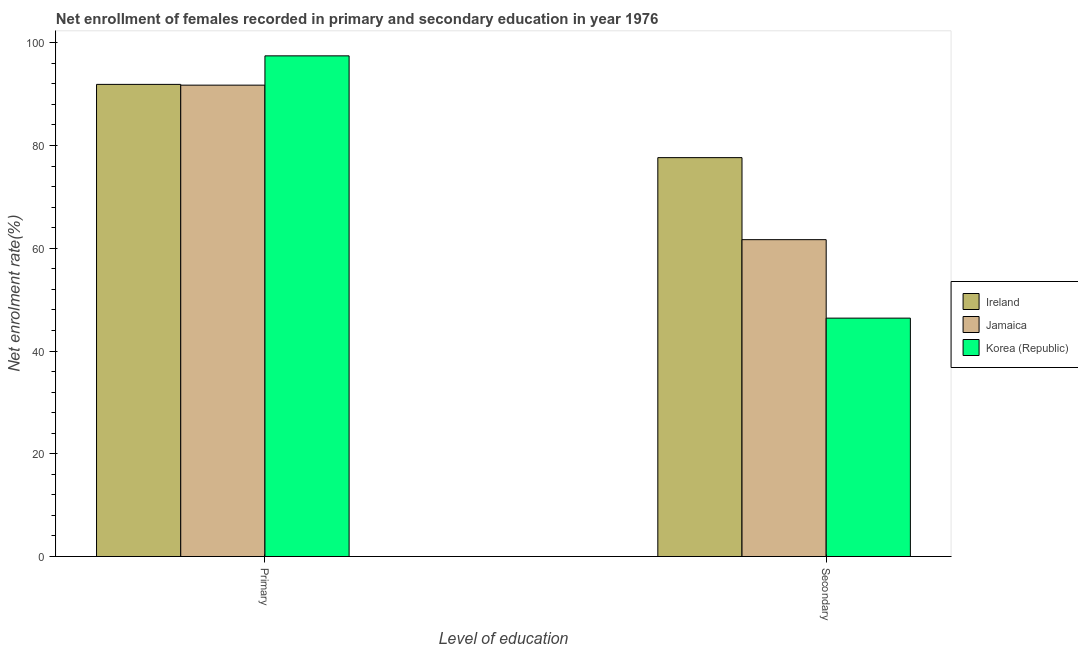Are the number of bars per tick equal to the number of legend labels?
Provide a short and direct response. Yes. Are the number of bars on each tick of the X-axis equal?
Ensure brevity in your answer.  Yes. What is the label of the 2nd group of bars from the left?
Your answer should be very brief. Secondary. What is the enrollment rate in primary education in Korea (Republic)?
Make the answer very short. 97.44. Across all countries, what is the maximum enrollment rate in primary education?
Provide a succinct answer. 97.44. Across all countries, what is the minimum enrollment rate in primary education?
Ensure brevity in your answer.  91.74. In which country was the enrollment rate in primary education minimum?
Offer a terse response. Jamaica. What is the total enrollment rate in secondary education in the graph?
Your answer should be compact. 185.7. What is the difference between the enrollment rate in primary education in Ireland and that in Jamaica?
Offer a terse response. 0.15. What is the difference between the enrollment rate in primary education in Jamaica and the enrollment rate in secondary education in Korea (Republic)?
Provide a succinct answer. 45.35. What is the average enrollment rate in secondary education per country?
Ensure brevity in your answer.  61.9. What is the difference between the enrollment rate in secondary education and enrollment rate in primary education in Jamaica?
Keep it short and to the point. -30.08. What is the ratio of the enrollment rate in primary education in Korea (Republic) to that in Ireland?
Keep it short and to the point. 1.06. Is the enrollment rate in secondary education in Ireland less than that in Jamaica?
Give a very brief answer. No. What does the 1st bar from the left in Secondary represents?
Give a very brief answer. Ireland. What does the 3rd bar from the right in Primary represents?
Offer a very short reply. Ireland. Are all the bars in the graph horizontal?
Ensure brevity in your answer.  No. How many countries are there in the graph?
Keep it short and to the point. 3. Does the graph contain grids?
Your answer should be very brief. No. How are the legend labels stacked?
Ensure brevity in your answer.  Vertical. What is the title of the graph?
Offer a terse response. Net enrollment of females recorded in primary and secondary education in year 1976. Does "Yemen, Rep." appear as one of the legend labels in the graph?
Make the answer very short. No. What is the label or title of the X-axis?
Provide a succinct answer. Level of education. What is the label or title of the Y-axis?
Provide a short and direct response. Net enrolment rate(%). What is the Net enrolment rate(%) of Ireland in Primary?
Your answer should be very brief. 91.89. What is the Net enrolment rate(%) in Jamaica in Primary?
Give a very brief answer. 91.74. What is the Net enrolment rate(%) in Korea (Republic) in Primary?
Your answer should be very brief. 97.44. What is the Net enrolment rate(%) of Ireland in Secondary?
Keep it short and to the point. 77.63. What is the Net enrolment rate(%) of Jamaica in Secondary?
Ensure brevity in your answer.  61.67. What is the Net enrolment rate(%) of Korea (Republic) in Secondary?
Provide a short and direct response. 46.4. Across all Level of education, what is the maximum Net enrolment rate(%) of Ireland?
Your answer should be compact. 91.89. Across all Level of education, what is the maximum Net enrolment rate(%) of Jamaica?
Keep it short and to the point. 91.74. Across all Level of education, what is the maximum Net enrolment rate(%) of Korea (Republic)?
Keep it short and to the point. 97.44. Across all Level of education, what is the minimum Net enrolment rate(%) of Ireland?
Provide a short and direct response. 77.63. Across all Level of education, what is the minimum Net enrolment rate(%) in Jamaica?
Your answer should be very brief. 61.67. Across all Level of education, what is the minimum Net enrolment rate(%) in Korea (Republic)?
Offer a terse response. 46.4. What is the total Net enrolment rate(%) of Ireland in the graph?
Offer a terse response. 169.53. What is the total Net enrolment rate(%) of Jamaica in the graph?
Make the answer very short. 153.41. What is the total Net enrolment rate(%) in Korea (Republic) in the graph?
Your answer should be compact. 143.84. What is the difference between the Net enrolment rate(%) of Ireland in Primary and that in Secondary?
Provide a succinct answer. 14.26. What is the difference between the Net enrolment rate(%) in Jamaica in Primary and that in Secondary?
Ensure brevity in your answer.  30.08. What is the difference between the Net enrolment rate(%) in Korea (Republic) in Primary and that in Secondary?
Your answer should be very brief. 51.05. What is the difference between the Net enrolment rate(%) in Ireland in Primary and the Net enrolment rate(%) in Jamaica in Secondary?
Provide a succinct answer. 30.22. What is the difference between the Net enrolment rate(%) of Ireland in Primary and the Net enrolment rate(%) of Korea (Republic) in Secondary?
Give a very brief answer. 45.49. What is the difference between the Net enrolment rate(%) in Jamaica in Primary and the Net enrolment rate(%) in Korea (Republic) in Secondary?
Make the answer very short. 45.35. What is the average Net enrolment rate(%) in Ireland per Level of education?
Make the answer very short. 84.76. What is the average Net enrolment rate(%) in Jamaica per Level of education?
Offer a terse response. 76.7. What is the average Net enrolment rate(%) in Korea (Republic) per Level of education?
Make the answer very short. 71.92. What is the difference between the Net enrolment rate(%) in Ireland and Net enrolment rate(%) in Jamaica in Primary?
Provide a short and direct response. 0.15. What is the difference between the Net enrolment rate(%) in Ireland and Net enrolment rate(%) in Korea (Republic) in Primary?
Your response must be concise. -5.55. What is the difference between the Net enrolment rate(%) of Jamaica and Net enrolment rate(%) of Korea (Republic) in Primary?
Provide a succinct answer. -5.7. What is the difference between the Net enrolment rate(%) in Ireland and Net enrolment rate(%) in Jamaica in Secondary?
Your response must be concise. 15.97. What is the difference between the Net enrolment rate(%) in Ireland and Net enrolment rate(%) in Korea (Republic) in Secondary?
Make the answer very short. 31.24. What is the difference between the Net enrolment rate(%) of Jamaica and Net enrolment rate(%) of Korea (Republic) in Secondary?
Provide a succinct answer. 15.27. What is the ratio of the Net enrolment rate(%) in Ireland in Primary to that in Secondary?
Ensure brevity in your answer.  1.18. What is the ratio of the Net enrolment rate(%) in Jamaica in Primary to that in Secondary?
Your response must be concise. 1.49. What is the ratio of the Net enrolment rate(%) of Korea (Republic) in Primary to that in Secondary?
Offer a very short reply. 2.1. What is the difference between the highest and the second highest Net enrolment rate(%) of Ireland?
Provide a short and direct response. 14.26. What is the difference between the highest and the second highest Net enrolment rate(%) in Jamaica?
Make the answer very short. 30.08. What is the difference between the highest and the second highest Net enrolment rate(%) of Korea (Republic)?
Your answer should be compact. 51.05. What is the difference between the highest and the lowest Net enrolment rate(%) in Ireland?
Ensure brevity in your answer.  14.26. What is the difference between the highest and the lowest Net enrolment rate(%) of Jamaica?
Ensure brevity in your answer.  30.08. What is the difference between the highest and the lowest Net enrolment rate(%) in Korea (Republic)?
Provide a succinct answer. 51.05. 